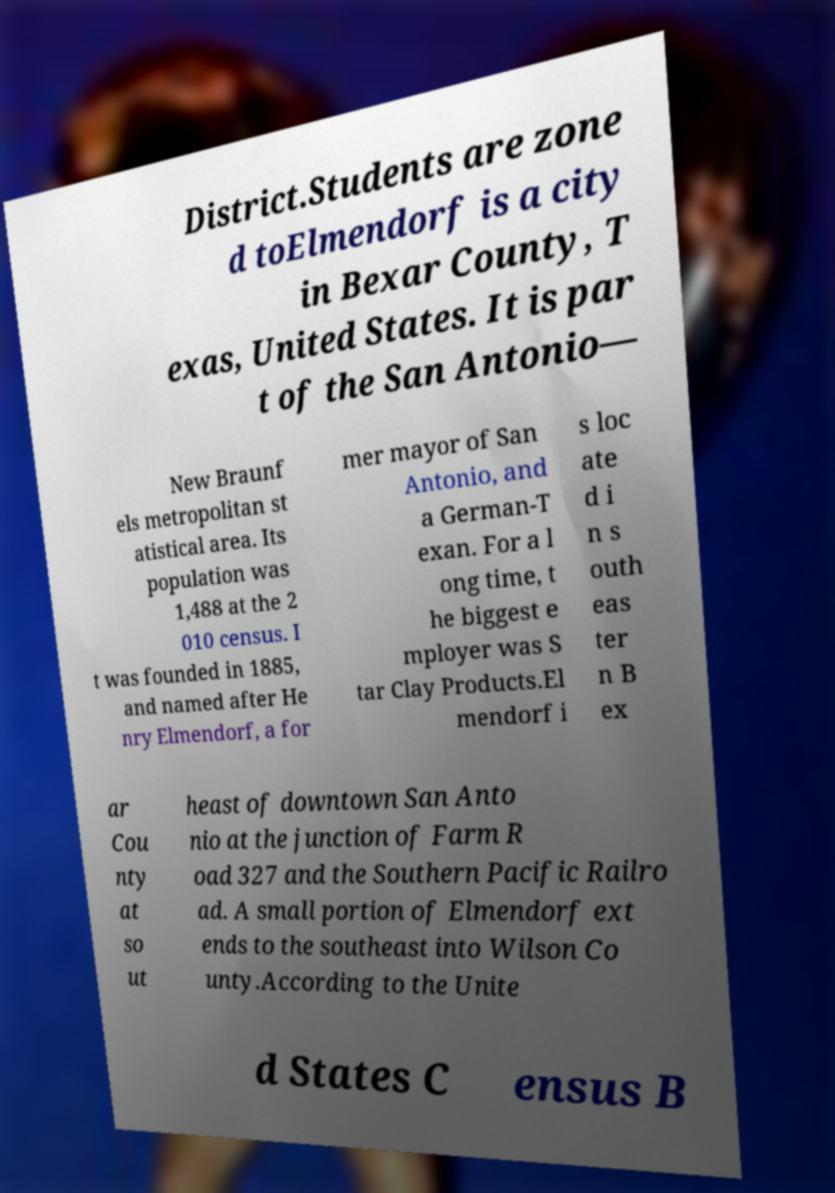Can you read and provide the text displayed in the image?This photo seems to have some interesting text. Can you extract and type it out for me? District.Students are zone d toElmendorf is a city in Bexar County, T exas, United States. It is par t of the San Antonio— New Braunf els metropolitan st atistical area. Its population was 1,488 at the 2 010 census. I t was founded in 1885, and named after He nry Elmendorf, a for mer mayor of San Antonio, and a German-T exan. For a l ong time, t he biggest e mployer was S tar Clay Products.El mendorf i s loc ate d i n s outh eas ter n B ex ar Cou nty at so ut heast of downtown San Anto nio at the junction of Farm R oad 327 and the Southern Pacific Railro ad. A small portion of Elmendorf ext ends to the southeast into Wilson Co unty.According to the Unite d States C ensus B 